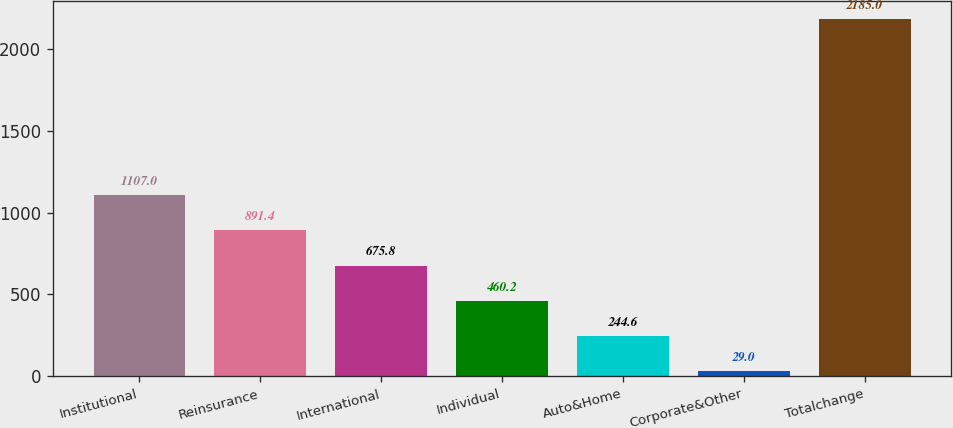Convert chart. <chart><loc_0><loc_0><loc_500><loc_500><bar_chart><fcel>Institutional<fcel>Reinsurance<fcel>International<fcel>Individual<fcel>Auto&Home<fcel>Corporate&Other<fcel>Totalchange<nl><fcel>1107<fcel>891.4<fcel>675.8<fcel>460.2<fcel>244.6<fcel>29<fcel>2185<nl></chart> 